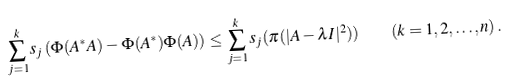<formula> <loc_0><loc_0><loc_500><loc_500>\sum _ { j = 1 } ^ { k } s _ { j } \left ( \Phi ( A ^ { * } A ) - \Phi ( A ^ { * } ) \Phi ( A ) \right ) \leq \sum _ { j = 1 } ^ { k } s _ { j } ( \pi ( | A - \lambda I | ^ { 2 } ) ) \quad ( k = 1 , 2 , \dots , n ) \, .</formula> 